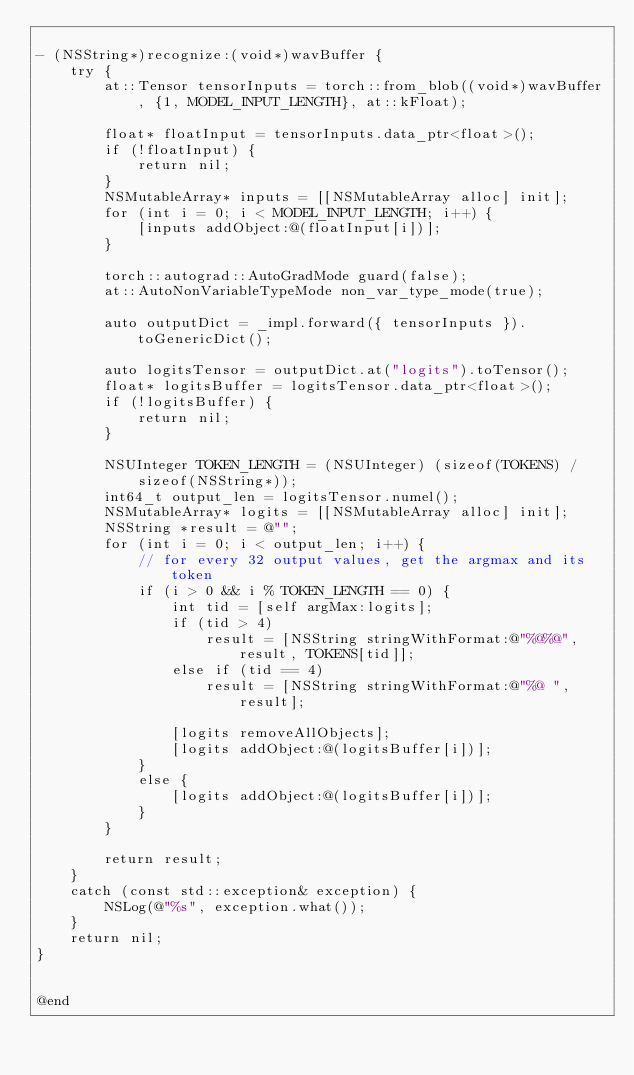Convert code to text. <code><loc_0><loc_0><loc_500><loc_500><_ObjectiveC_>
- (NSString*)recognize:(void*)wavBuffer {
    try {
        at::Tensor tensorInputs = torch::from_blob((void*)wavBuffer, {1, MODEL_INPUT_LENGTH}, at::kFloat);
        
        float* floatInput = tensorInputs.data_ptr<float>();
        if (!floatInput) {
            return nil;
        }
        NSMutableArray* inputs = [[NSMutableArray alloc] init];
        for (int i = 0; i < MODEL_INPUT_LENGTH; i++) {
            [inputs addObject:@(floatInput[i])];
        }
        
        torch::autograd::AutoGradMode guard(false);
        at::AutoNonVariableTypeMode non_var_type_mode(true);
    
        auto outputDict = _impl.forward({ tensorInputs }).toGenericDict();

        auto logitsTensor = outputDict.at("logits").toTensor();
        float* logitsBuffer = logitsTensor.data_ptr<float>();
        if (!logitsBuffer) {
            return nil;
        }
        
        NSUInteger TOKEN_LENGTH = (NSUInteger) (sizeof(TOKENS) / sizeof(NSString*));
        int64_t output_len = logitsTensor.numel();
        NSMutableArray* logits = [[NSMutableArray alloc] init];
        NSString *result = @"";
        for (int i = 0; i < output_len; i++) {
            // for every 32 output values, get the argmax and its token
            if (i > 0 && i % TOKEN_LENGTH == 0) {
                int tid = [self argMax:logits];
                if (tid > 4)
                    result = [NSString stringWithFormat:@"%@%@", result, TOKENS[tid]];
                else if (tid == 4)
                    result = [NSString stringWithFormat:@"%@ ", result];

                [logits removeAllObjects];
                [logits addObject:@(logitsBuffer[i])];
            }
            else {
                [logits addObject:@(logitsBuffer[i])];
            }
        }
        
        return result;
    }
    catch (const std::exception& exception) {
        NSLog(@"%s", exception.what());
    }
    return nil;
}


@end
</code> 